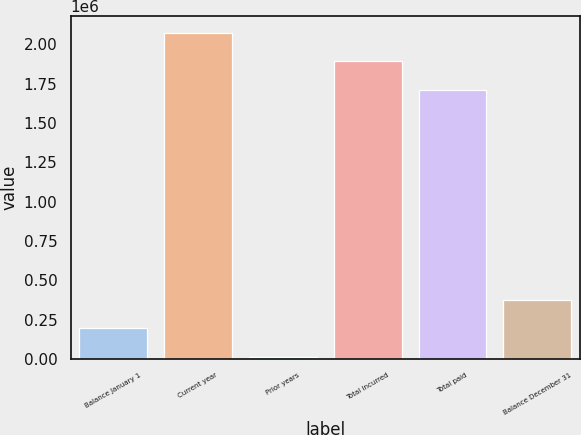Convert chart to OTSL. <chart><loc_0><loc_0><loc_500><loc_500><bar_chart><fcel>Balance January 1<fcel>Current year<fcel>Prior years<fcel>Total incurred<fcel>Total paid<fcel>Balance December 31<nl><fcel>194266<fcel>2.07563e+06<fcel>12285<fcel>1.89365e+06<fcel>1.71167e+06<fcel>376247<nl></chart> 